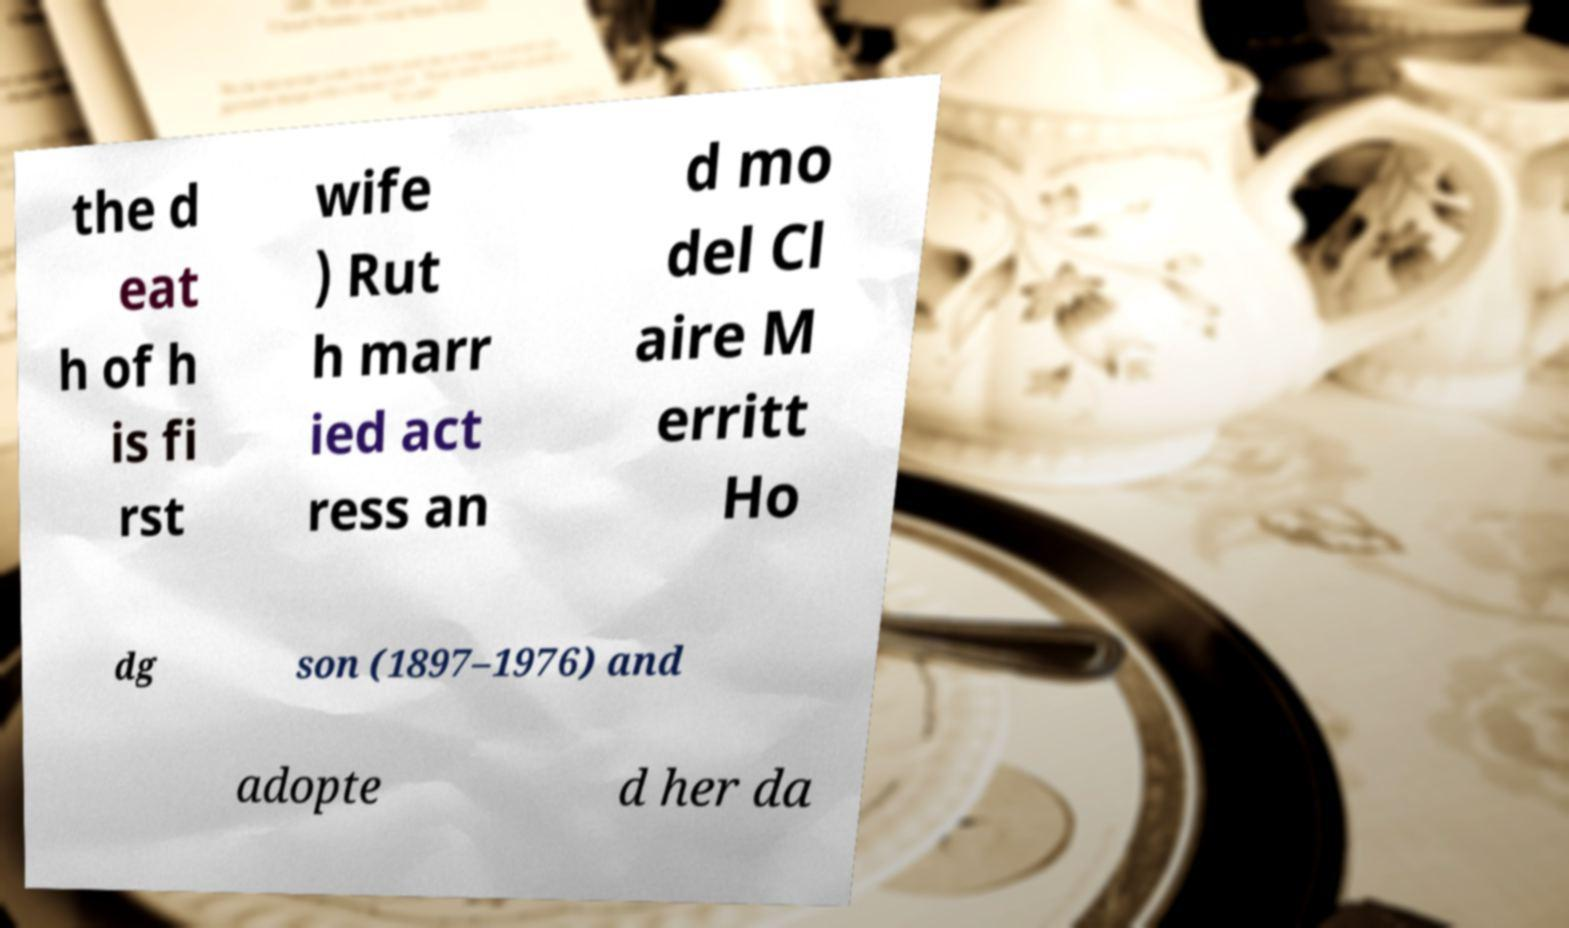I need the written content from this picture converted into text. Can you do that? the d eat h of h is fi rst wife ) Rut h marr ied act ress an d mo del Cl aire M erritt Ho dg son (1897–1976) and adopte d her da 